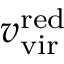Convert formula to latex. <formula><loc_0><loc_0><loc_500><loc_500>v _ { v i r } ^ { r e d }</formula> 